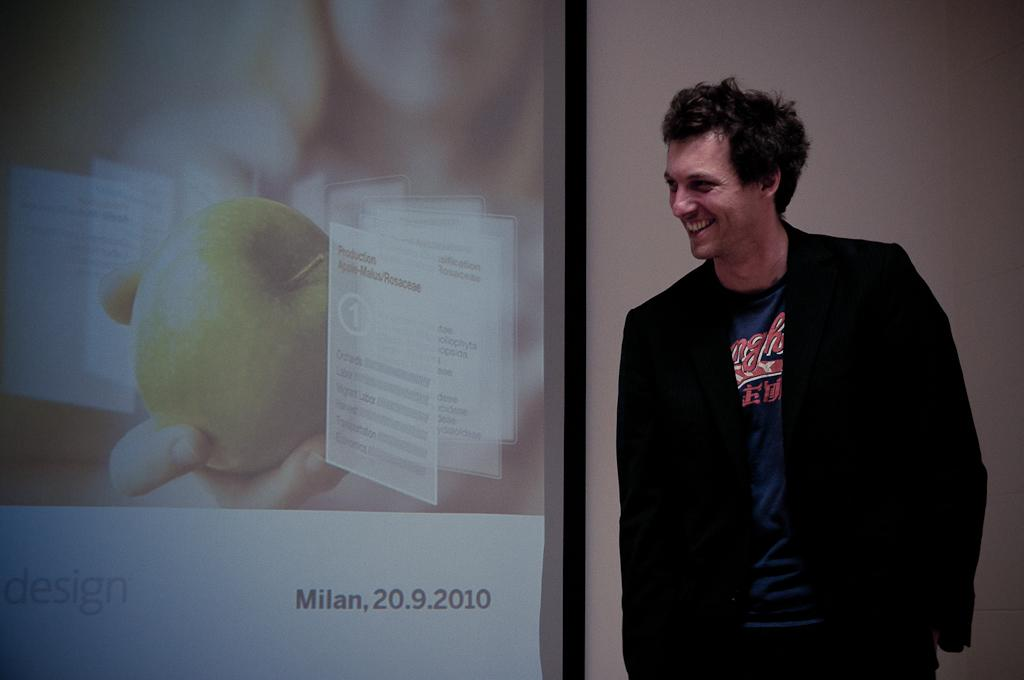<image>
Offer a succinct explanation of the picture presented. A man stands next to a display on which the word Milan is visible. 